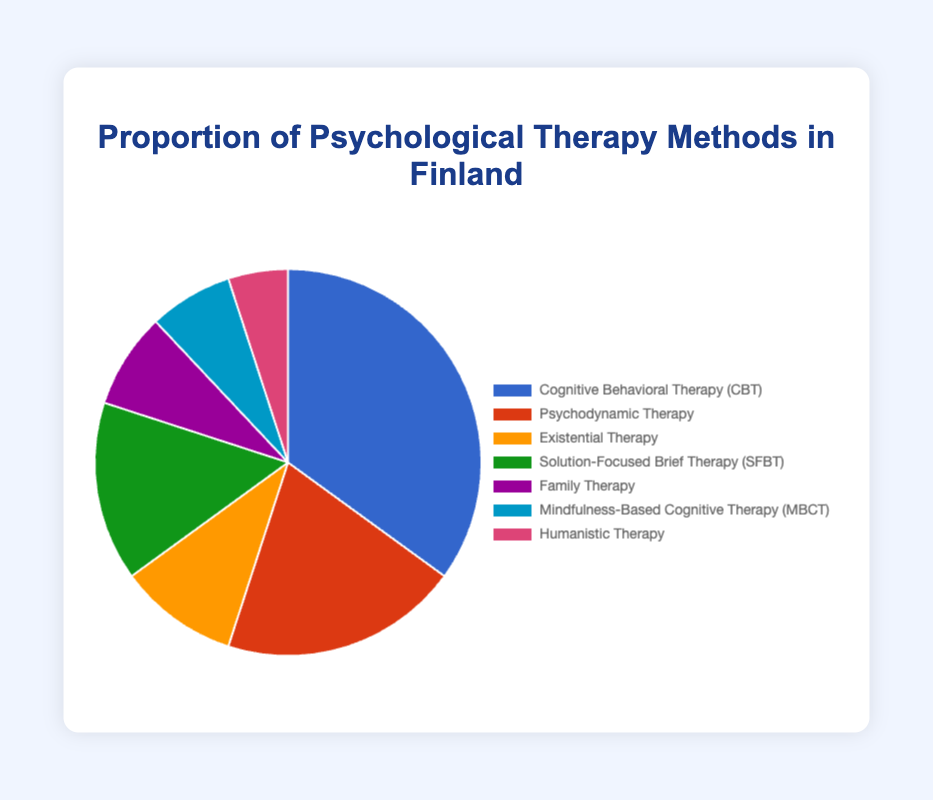Which therapy method is the most commonly used in Finland? The pie chart shows that Cognitive Behavioral Therapy (CBT) takes up the largest slice. So, it is the most commonly used therapy method in Finland.
Answer: Cognitive Behavioral Therapy (CBT) Which therapy method is the least commonly used in Finland? By looking at the pie chart, Humanistic Therapy has the smallest slice among all therapy methods, making it the least commonly used method.
Answer: Humanistic Therapy What is the combined percentage of Cognitive Behavioral Therapy (CBT) and Psychodynamic Therapy? According to the chart, Cognitive Behavioral Therapy (CBT) is 35% and Psychodynamic Therapy is 20%. Adding these numbers together gives 35% + 20% = 55%.
Answer: 55% How much more common is Solution-Focused Brief Therapy (SFBT) compared to Family Therapy? The pie chart shows that Solution-Focused Brief Therapy (SFBT) is 15% and Family Therapy is 8%. The difference between them is 15% - 8% = 7%.
Answer: 7% By what percentage is Existential Therapy more common than Mindfulness-Based Cognitive Therapy (MBCT)? Existential Therapy is 10% and Mindfulness-Based Cognitive Therapy (MBCT) is 7% as per the pie chart. The difference is 10% - 7% = 3%.
Answer: 3% What proportion of the therapy methods use colors from the blue spectrum? The chart shows that Cognitive Behavioral Therapy (CBT) and Mindfulness-Based Cognitive Therapy (MBCT) use blue tones. Their respective percentages are 35% and 7%. The combined proportion is 35% + 7% = 42%.
Answer: 42% Which two therapy methods together make up more than half of the therapy methods used? By observing the pie chart, Cognitive Behavioral Therapy (CBT) at 35% and Psychodynamic Therapy at 20% together sum up to 35% + 20% = 55%. This is more than half.
Answer: Cognitive Behavioral Therapy (CBT) and Psychodynamic Therapy If the proportions of all therapy methods except Mindfulness-Based Cognitive Therapy (MBCT) decreased by 2%, what will be the new proportion of (MBCT)? Original total percentage of all therapy methods is 100%. If all methods except MBCT decrease by 2%, total reduction is 6*2% = 12%. Original MBCT proportion is 7%. The new proportion of MBCT will be 7% + 12% = 19%.
Answer: 19% Which color represents the Psychodynamic Therapy method in the pie chart? The pie chart uses red to represent Psychodynamic Therapy. This can be identified by referring to the color legend associated with the chart.
Answer: Red 